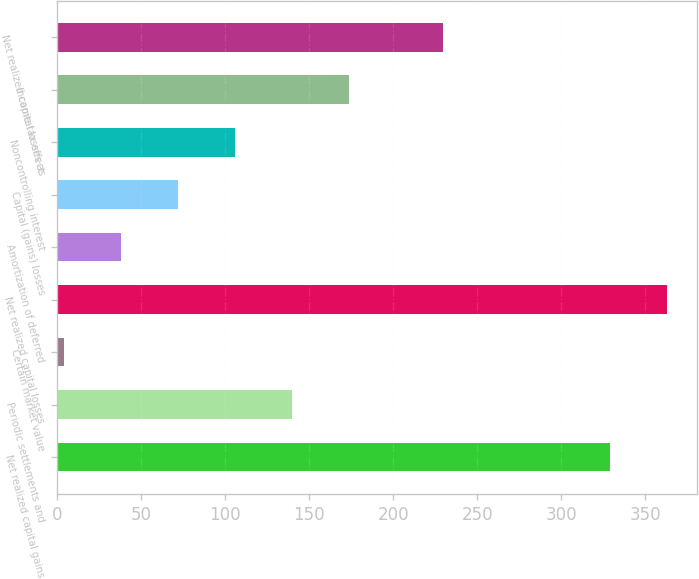Convert chart. <chart><loc_0><loc_0><loc_500><loc_500><bar_chart><fcel>Net realized capital gains<fcel>Periodic settlements and<fcel>Certain market value<fcel>Net realized capital losses<fcel>Amortization of deferred<fcel>Capital (gains) losses<fcel>Noncontrolling interest<fcel>Income tax effect<fcel>Net realized capital losses as<nl><fcel>328.8<fcel>139.6<fcel>4<fcel>362.7<fcel>37.9<fcel>71.8<fcel>105.7<fcel>173.5<fcel>229.7<nl></chart> 